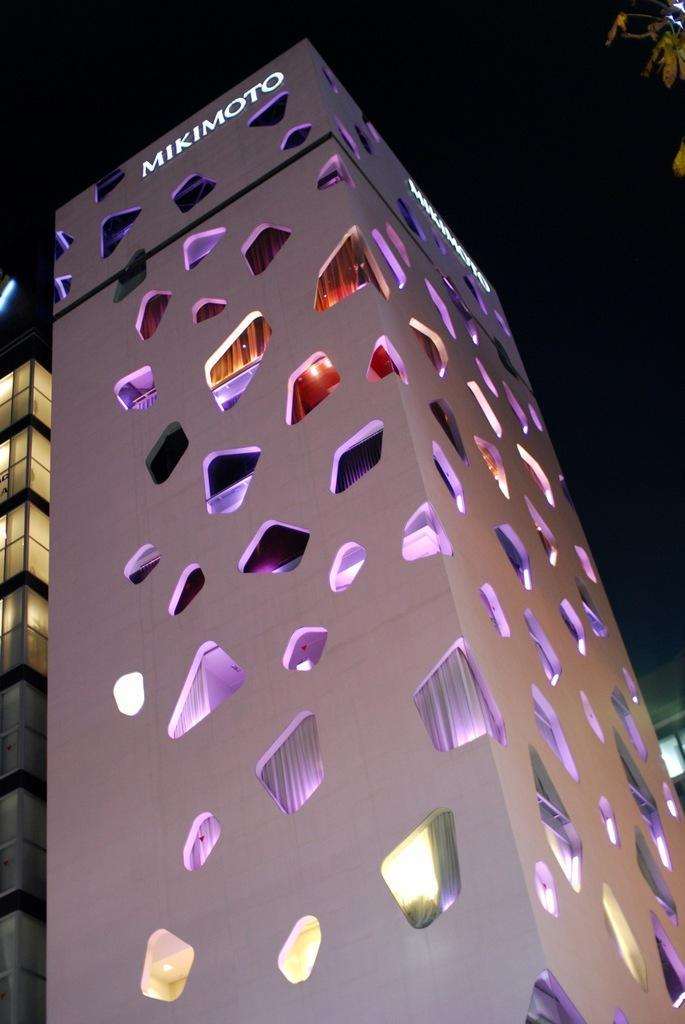In one or two sentences, can you explain what this image depicts? In the foreground of this image, there are two buildings. On the top, there is the dark sky and a tree on the top right corner. 